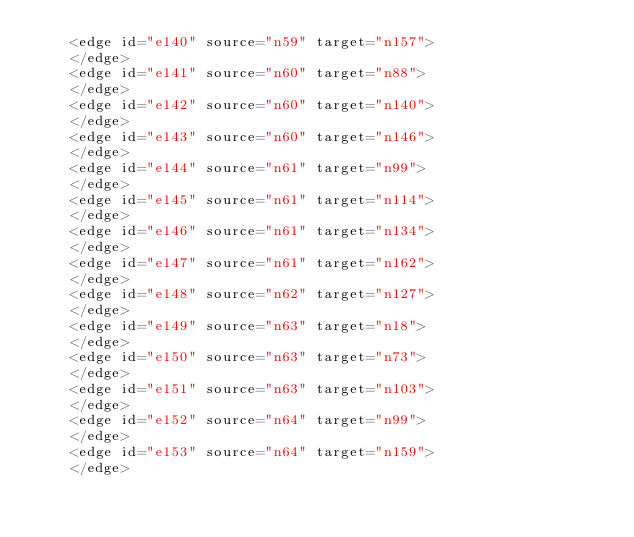Convert code to text. <code><loc_0><loc_0><loc_500><loc_500><_XML_>    <edge id="e140" source="n59" target="n157">
    </edge>
    <edge id="e141" source="n60" target="n88">
    </edge>
    <edge id="e142" source="n60" target="n140">
    </edge>
    <edge id="e143" source="n60" target="n146">
    </edge>
    <edge id="e144" source="n61" target="n99">
    </edge>
    <edge id="e145" source="n61" target="n114">
    </edge>
    <edge id="e146" source="n61" target="n134">
    </edge>
    <edge id="e147" source="n61" target="n162">
    </edge>
    <edge id="e148" source="n62" target="n127">
    </edge>
    <edge id="e149" source="n63" target="n18">
    </edge>
    <edge id="e150" source="n63" target="n73">
    </edge>
    <edge id="e151" source="n63" target="n103">
    </edge>
    <edge id="e152" source="n64" target="n99">
    </edge>
    <edge id="e153" source="n64" target="n159">
    </edge></code> 